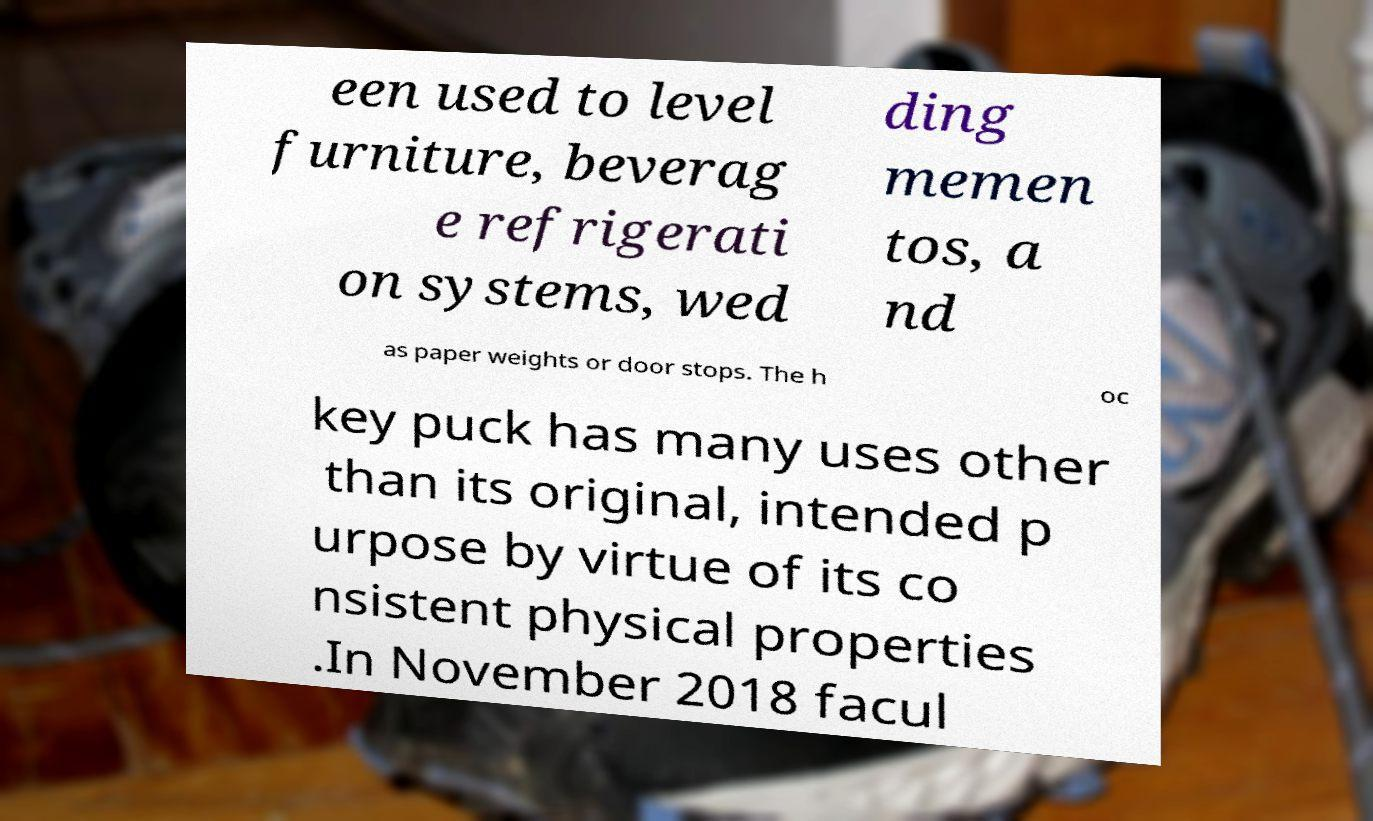What messages or text are displayed in this image? I need them in a readable, typed format. een used to level furniture, beverag e refrigerati on systems, wed ding memen tos, a nd as paper weights or door stops. The h oc key puck has many uses other than its original, intended p urpose by virtue of its co nsistent physical properties .In November 2018 facul 